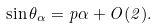<formula> <loc_0><loc_0><loc_500><loc_500>\sin \theta _ { \alpha } = { p \alpha } + O ( { 2 } ) .</formula> 